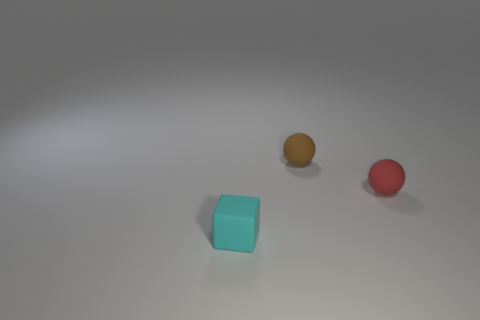Add 3 small matte blocks. How many objects exist? 6 Subtract all balls. How many objects are left? 1 Add 3 cyan cubes. How many cyan cubes exist? 4 Subtract 0 cyan cylinders. How many objects are left? 3 Subtract all metallic cylinders. Subtract all tiny brown matte objects. How many objects are left? 2 Add 1 brown balls. How many brown balls are left? 2 